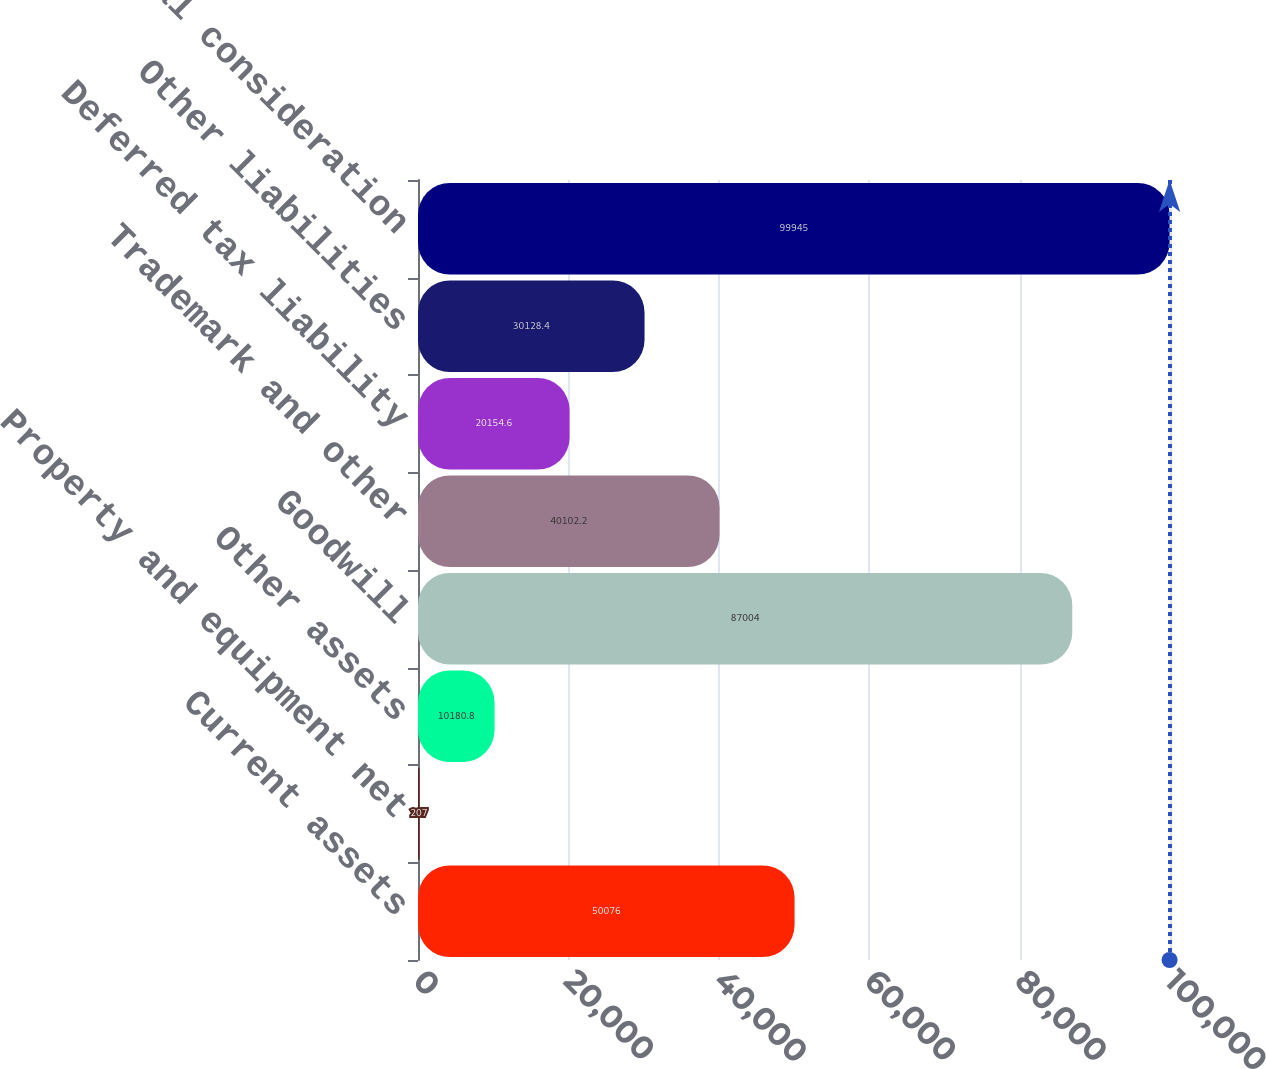Convert chart to OTSL. <chart><loc_0><loc_0><loc_500><loc_500><bar_chart><fcel>Current assets<fcel>Property and equipment net<fcel>Other assets<fcel>Goodwill<fcel>Trademark and other<fcel>Deferred tax liability<fcel>Other liabilities<fcel>Total consideration<nl><fcel>50076<fcel>207<fcel>10180.8<fcel>87004<fcel>40102.2<fcel>20154.6<fcel>30128.4<fcel>99945<nl></chart> 